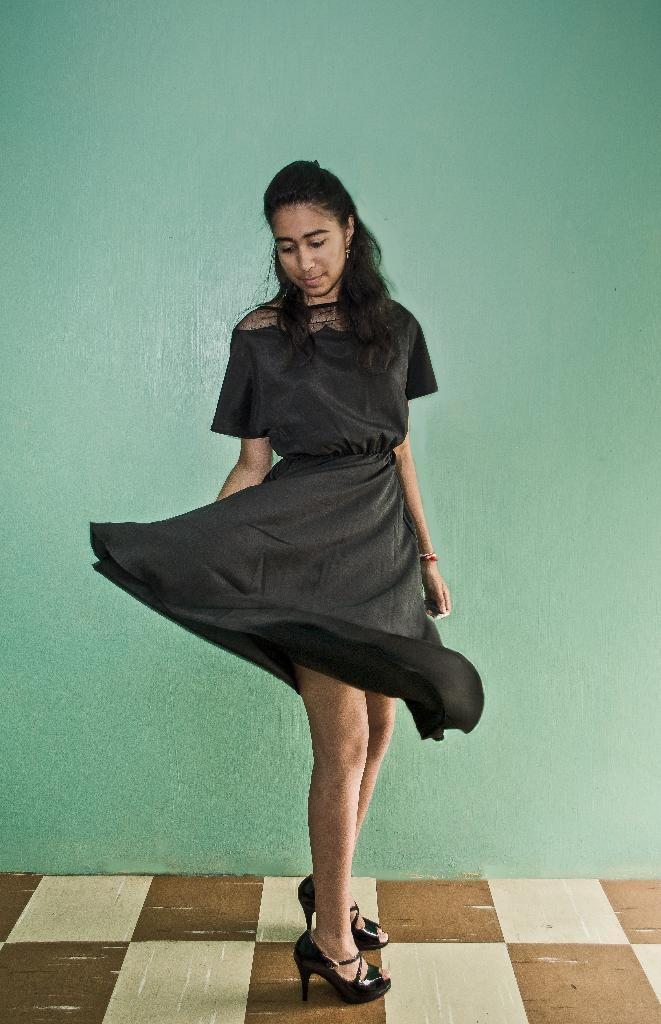Who is the main subject in the image? There is a girl in the image. What is the girl doing in the image? The girl is standing. What is the girl wearing in the image? The girl is wearing a black dress and black sandals. What can be seen in the background of the image? There is a green color wall in the background of the image. Are there any bears touching the girl's dress in the image? No, there are no bears present in the image, and the girl's dress is not being touched by any animals. Can you see a brush in the girl's hand in the image? No, there is no brush visible in the girl's hand in the image. 